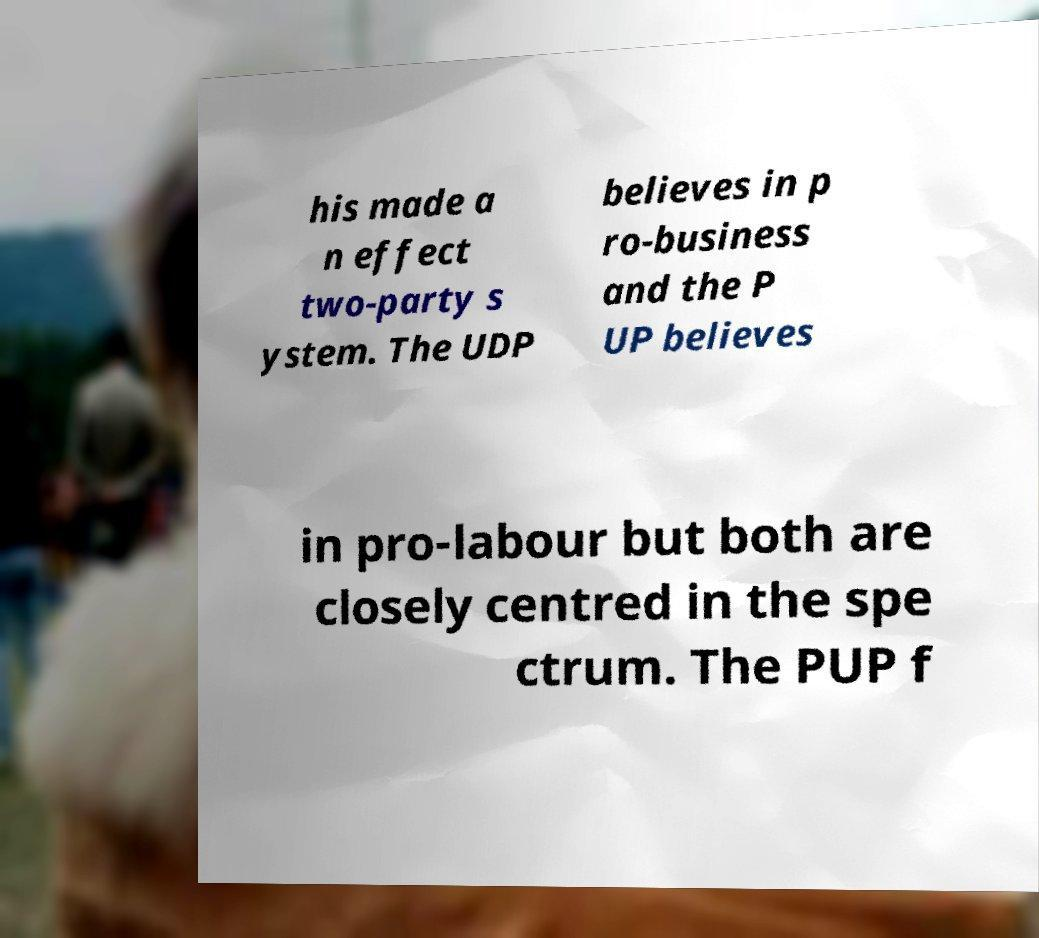Can you accurately transcribe the text from the provided image for me? his made a n effect two-party s ystem. The UDP believes in p ro-business and the P UP believes in pro-labour but both are closely centred in the spe ctrum. The PUP f 